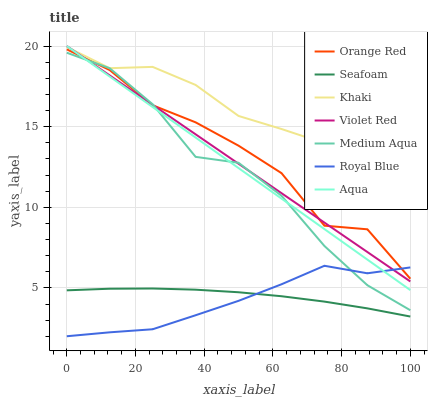Does Aqua have the minimum area under the curve?
Answer yes or no. No. Does Aqua have the maximum area under the curve?
Answer yes or no. No. Is Khaki the smoothest?
Answer yes or no. No. Is Khaki the roughest?
Answer yes or no. No. Does Aqua have the lowest value?
Answer yes or no. No. Does Khaki have the highest value?
Answer yes or no. No. Is Seafoam less than Medium Aqua?
Answer yes or no. Yes. Is Khaki greater than Orange Red?
Answer yes or no. Yes. Does Seafoam intersect Medium Aqua?
Answer yes or no. No. 